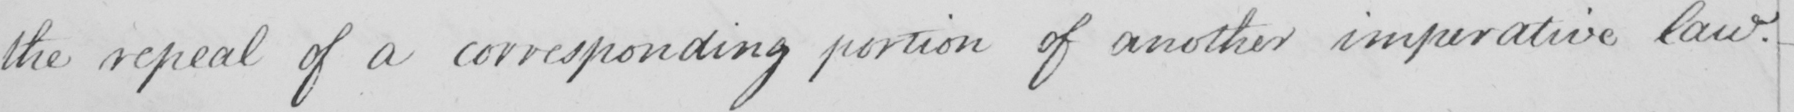Please provide the text content of this handwritten line. the repeal of a corresponding portion of another imperative law .  _ 